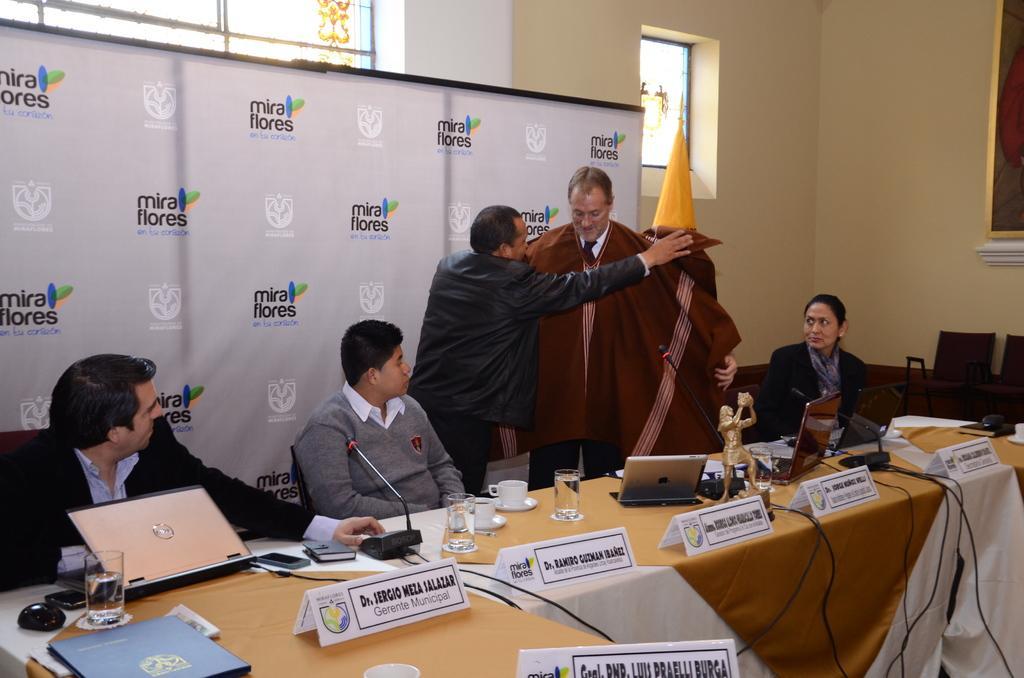Can you describe this image briefly? This picture is of inside the conference room. In the foreground we can see a table on the top of which a sculpture, glasses of water, cups, microphones, mobile phones and name plates are placed, behind that there are two men standing. On the left there are two persons sitting on the chairs and on the right there is a woman sitting on the chair. In the background we can see the white color banner, window, door and a yellow color flag. 